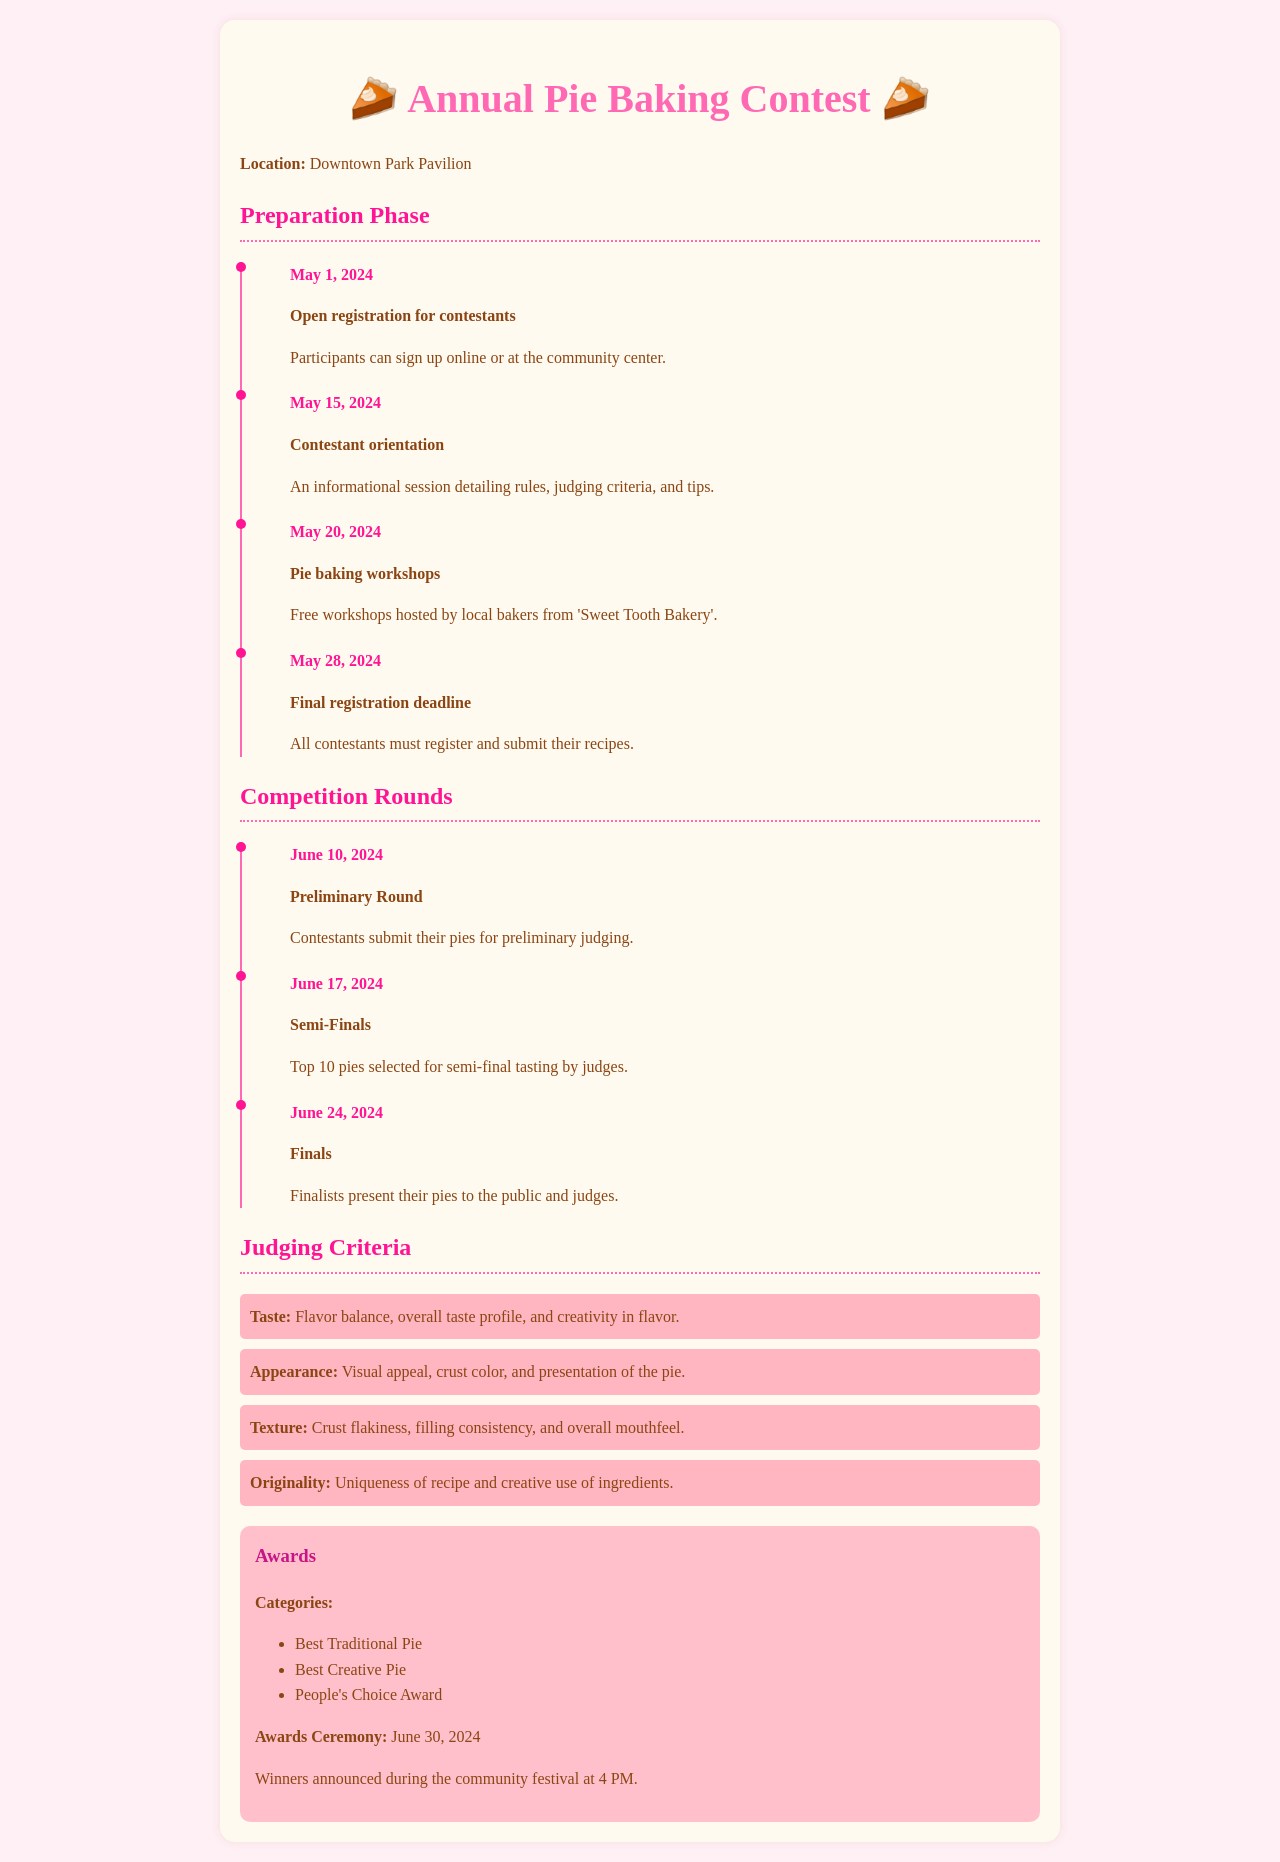What is the location of the contest? The document states that the location of the contest is Downtown Park Pavilion.
Answer: Downtown Park Pavilion When does the final registration deadline occur? The final registration deadline is mentioned as May 28, 2024.
Answer: May 28, 2024 What are the dates of the competition rounds? The competition rounds are scheduled from June 10, 2024, to June 24, 2024, as listed in the timeline.
Answer: June 10, 2024, to June 24, 2024 How many judging criteria are listed in the document? The document lists four judging criteria for the contest.
Answer: Four What is one of the award categories mentioned? The document states that one of the award categories is Best Traditional Pie.
Answer: Best Traditional Pie What event follows the Semi-Finals? The event that follows the Semi-Finals is the Finals, scheduled for June 24, 2024.
Answer: Finals What type of workshops are hosted on May 20, 2024? The workshops held on that date are pie baking workshops.
Answer: Pie baking workshops What is the awards ceremony date? The document states that the awards ceremony is on June 30, 2024.
Answer: June 30, 2024 Which bakery is hosting the pie baking workshops? The workshops are hosted by local bakers from 'Sweet Tooth Bakery'.
Answer: Sweet Tooth Bakery 